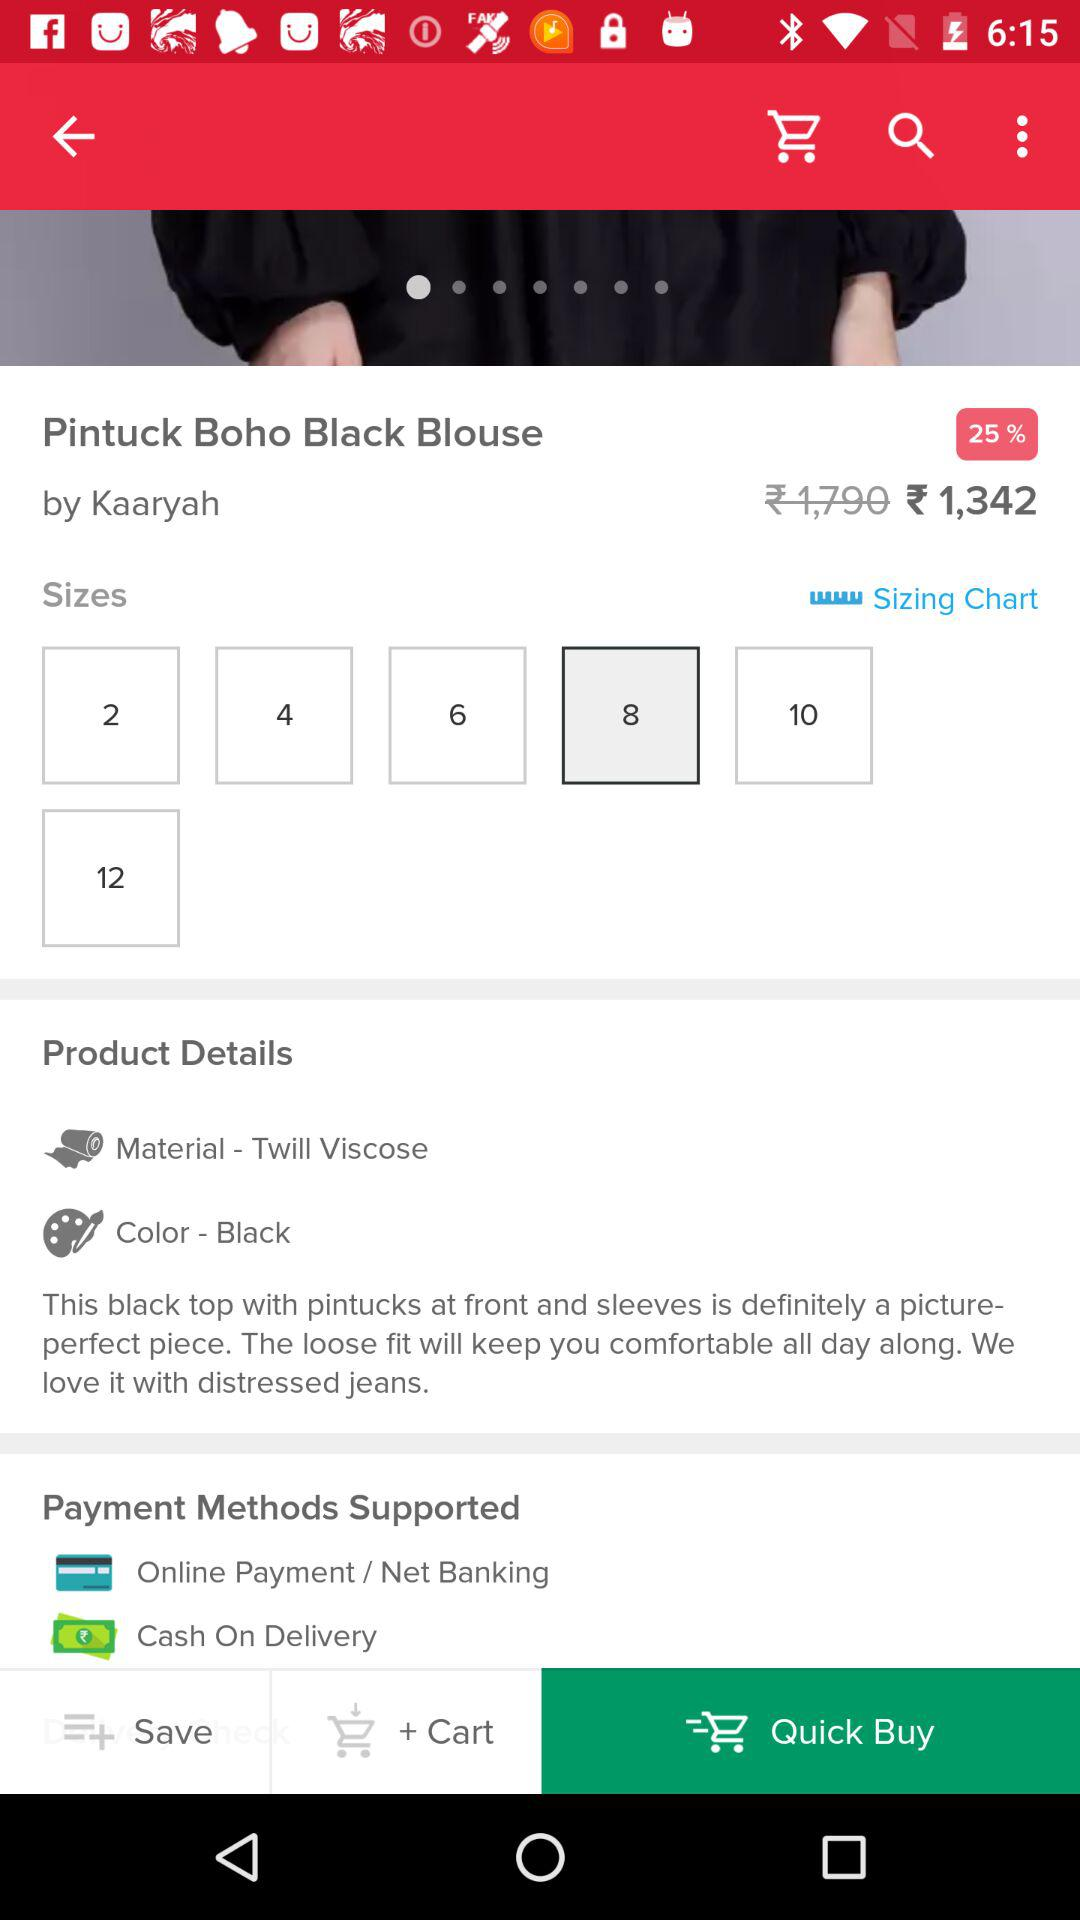How much percent of discount is there on the blouse? There is a discount of 25% on the blouse. 